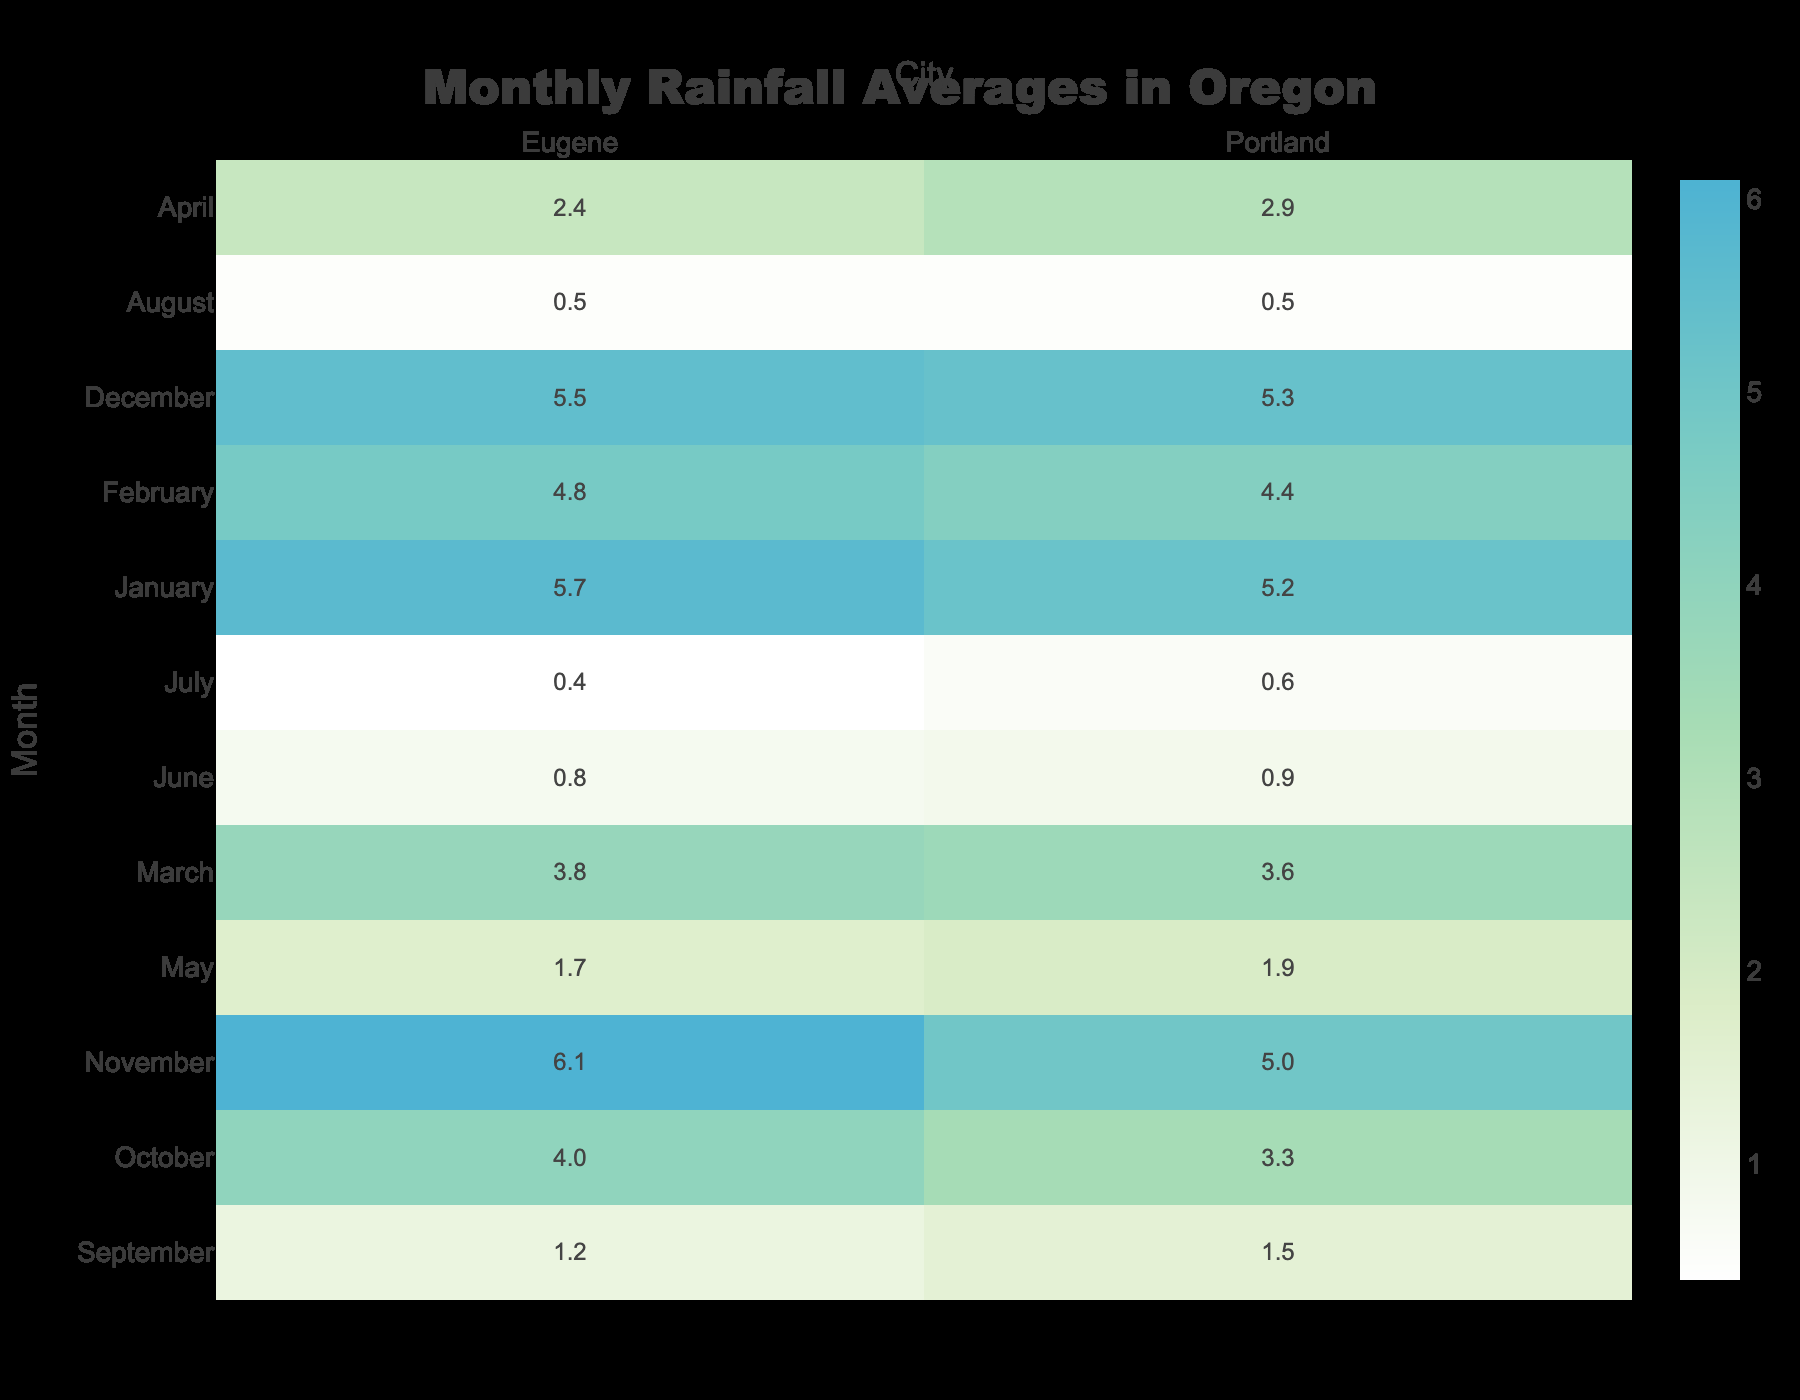What is the rainfall average in Portland for May? According to the table, the rainfall average for May in Portland is listed directly under the month of May in the Portland column, which shows 1.9 inches.
Answer: 1.9 inches Which month has the highest rainfall average in Eugene? By inspecting the rainfall averages for Eugene in the table, the highest value is found in November, where it shows 6.1 inches.
Answer: 6.1 inches What is the temperature average in Portland during April? The table indicates that the temperature average for April in Portland is 54°F, as it corresponds to the April row under the temperature column for Portland.
Answer: 54°F Is the outdoor training condition in Eugene during August classified as excellent? The data presents the outdoor training condition for Eugene in August as "Excellent," indicating that the condition is indeed excellent for that month.
Answer: Yes In which month does Portland have poorer outdoor training conditions than Eugene? Comparing the outdoor training conditions for each month in the table, we see that December in Portland is listed as "Poor," while in Eugene it is also "Poor." Thus, none of the months show Portland with poorer conditions than Eugene; they have the same poor condition in December, but in all other months, Eugene has equal or better ratings.
Answer: None What is the average rainfall for Portland and Eugene in July? For both cities, the rainfall average in July is taken from the respective rows: Portland has 0.6 inches and Eugene has 0.4 inches. The average can be calculated as (0.6 + 0.4) / 2 = 1.0 inch.
Answer: 1.0 inch How many months have a rainfall average below 1 inch in Portland? Observing the monthly rainfall averages for Portland, we find that only July (0.6 inches) and August (0.5 inches) have a rainfall average below 1 inch, resulting in a total of 2 months.
Answer: 2 months What is the total rainfall average for Portland from January to March? Adding up the rainfall averages from January (5.2 inches), February (4.4 inches), and March (3.6 inches) gives us a total of 5.2 + 4.4 + 3.6 = 13.2 inches.
Answer: 13.2 inches In which month does Eugene have the lowest rainfall average? Looking through Eugene's rainfall averages, the lowest value occurs in July, where the average is 0.4 inches, making it the month with the least rainfall.
Answer: July 